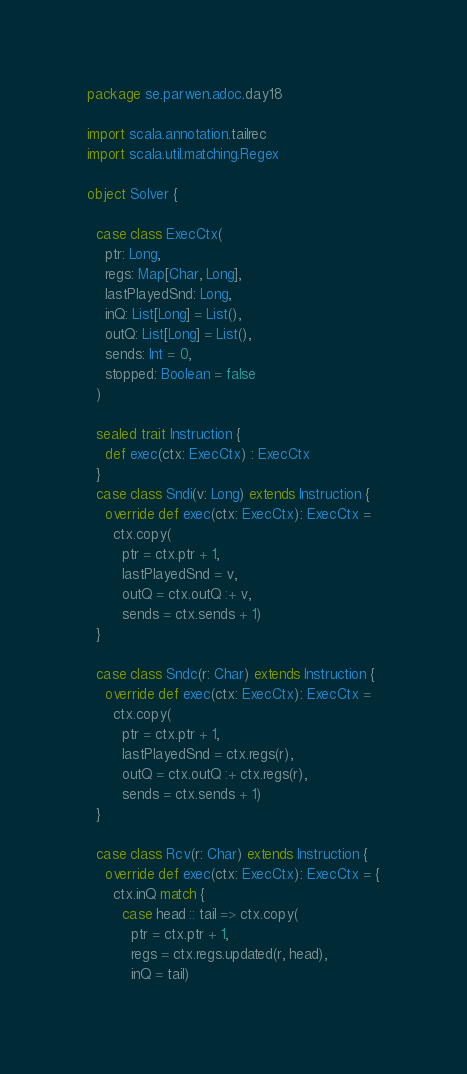Convert code to text. <code><loc_0><loc_0><loc_500><loc_500><_Scala_>package se.parwen.adoc.day18

import scala.annotation.tailrec
import scala.util.matching.Regex

object Solver {

  case class ExecCtx(
    ptr: Long,
    regs: Map[Char, Long],
    lastPlayedSnd: Long,
    inQ: List[Long] = List(),
    outQ: List[Long] = List(),
    sends: Int = 0,
    stopped: Boolean = false
  )

  sealed trait Instruction {
    def exec(ctx: ExecCtx) : ExecCtx
  }
  case class Sndi(v: Long) extends Instruction {
    override def exec(ctx: ExecCtx): ExecCtx =
      ctx.copy(
        ptr = ctx.ptr + 1,
        lastPlayedSnd = v,
        outQ = ctx.outQ :+ v,
        sends = ctx.sends + 1)
  }

  case class Sndc(r: Char) extends Instruction {
    override def exec(ctx: ExecCtx): ExecCtx =
      ctx.copy(
        ptr = ctx.ptr + 1,
        lastPlayedSnd = ctx.regs(r),
        outQ = ctx.outQ :+ ctx.regs(r),
        sends = ctx.sends + 1)
  }

  case class Rcv(r: Char) extends Instruction {
    override def exec(ctx: ExecCtx): ExecCtx = {
      ctx.inQ match {
        case head :: tail => ctx.copy(
          ptr = ctx.ptr + 1,
          regs = ctx.regs.updated(r, head),
          inQ = tail)</code> 